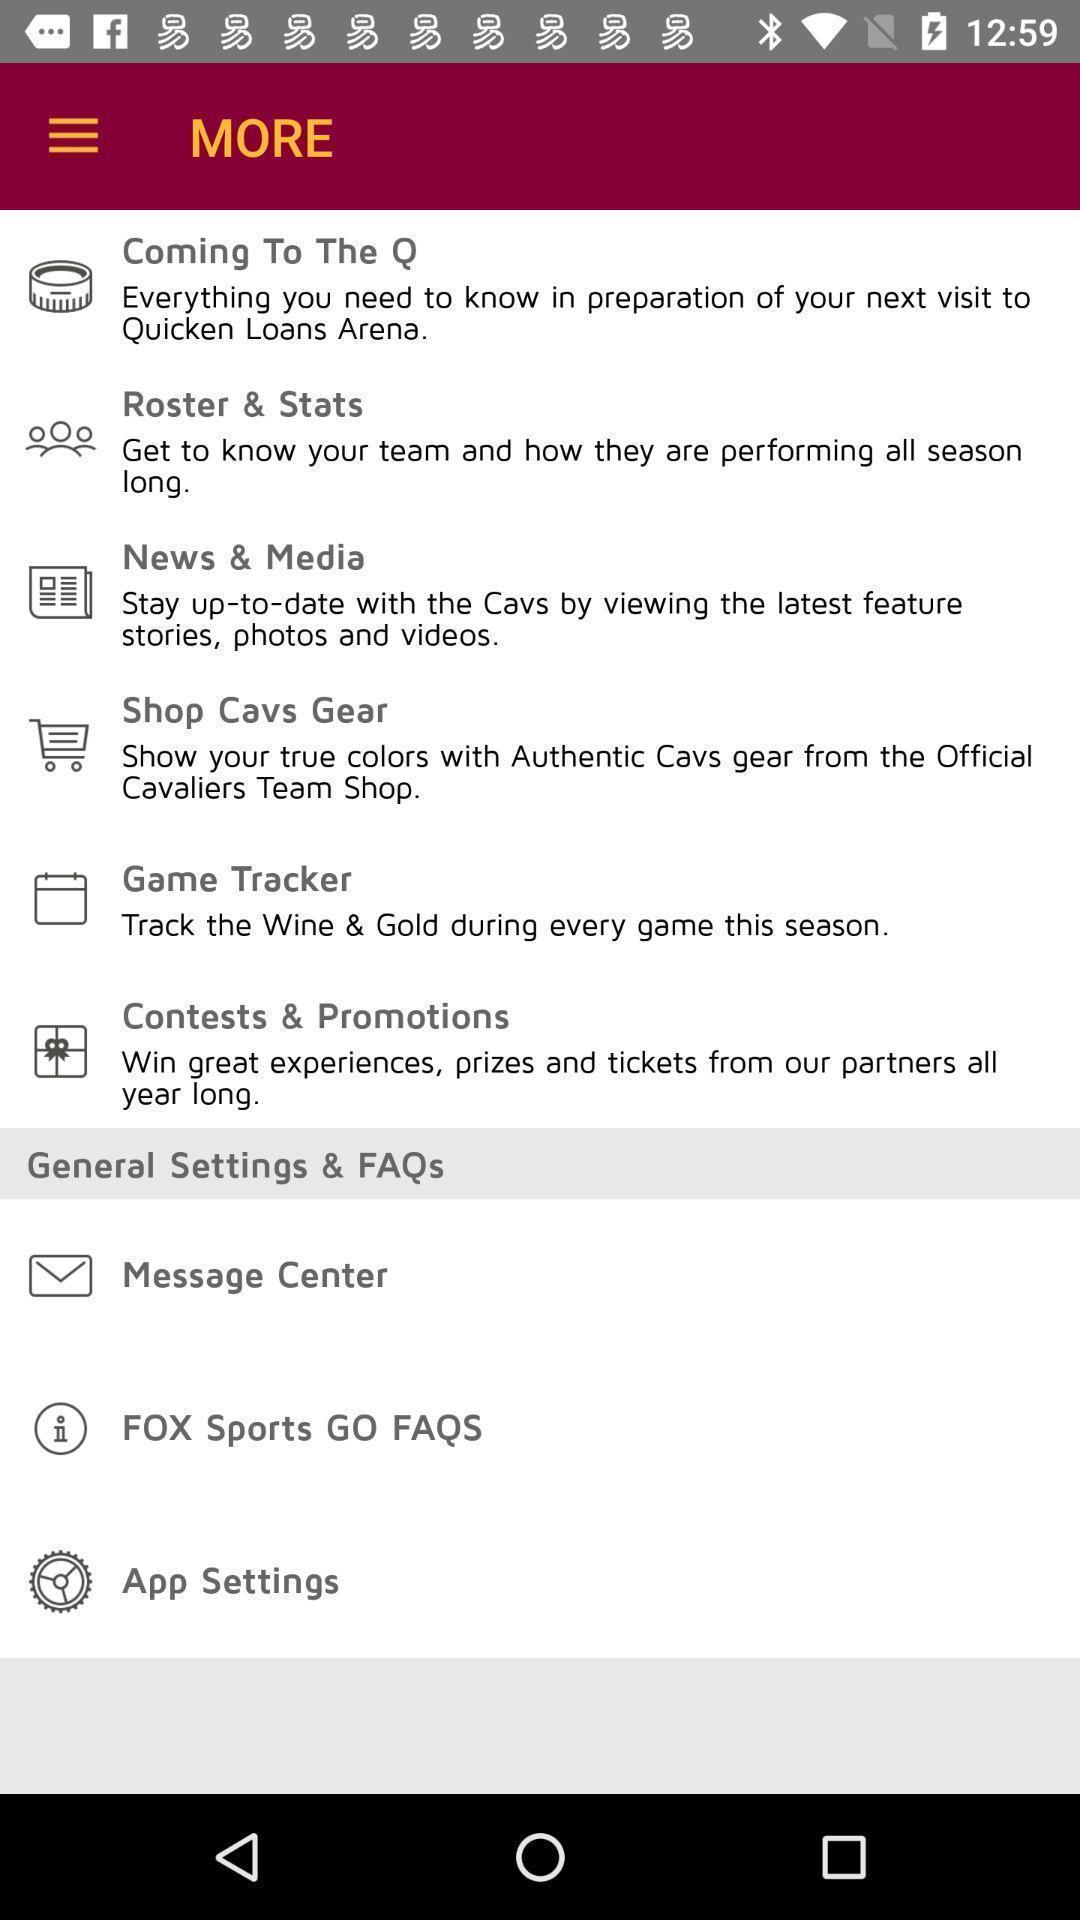Provide a description of this screenshot. Page showing different options in more. 